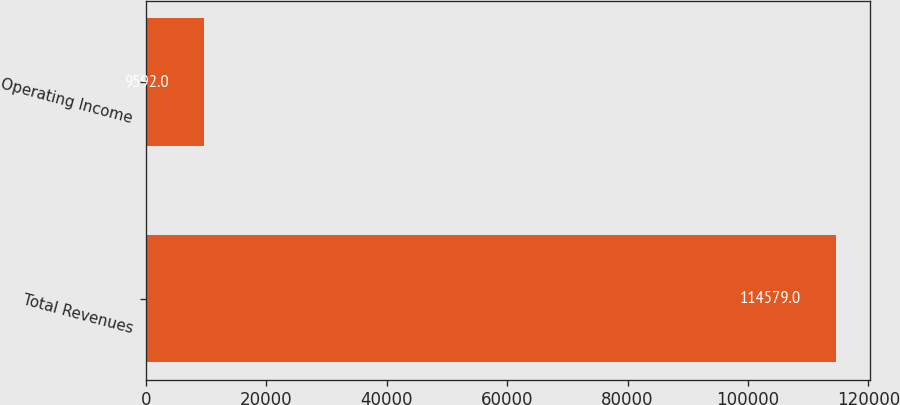Convert chart. <chart><loc_0><loc_0><loc_500><loc_500><bar_chart><fcel>Total Revenues<fcel>Operating Income<nl><fcel>114579<fcel>9592<nl></chart> 